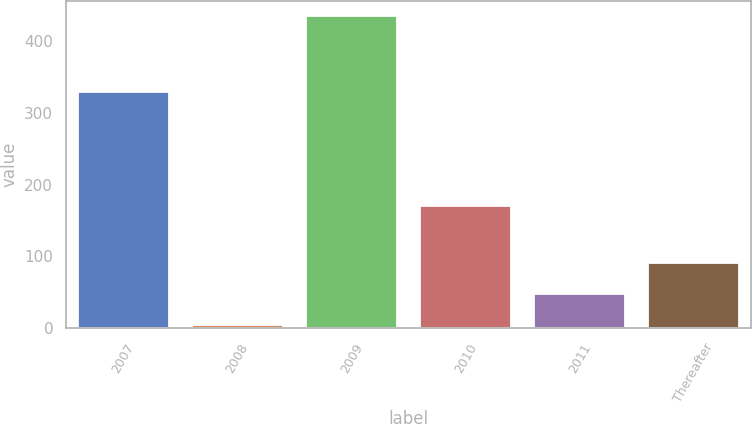Convert chart. <chart><loc_0><loc_0><loc_500><loc_500><bar_chart><fcel>2007<fcel>2008<fcel>2009<fcel>2010<fcel>2011<fcel>Thereafter<nl><fcel>330<fcel>5<fcel>435<fcel>170<fcel>48<fcel>91<nl></chart> 